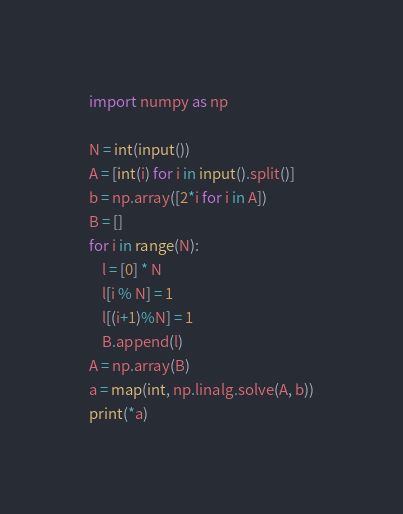<code> <loc_0><loc_0><loc_500><loc_500><_Python_>import numpy as np

N = int(input())
A = [int(i) for i in input().split()]
b = np.array([2*i for i in A])
B = []
for i in range(N):
    l = [0] * N
    l[i % N] = 1
    l[(i+1)%N] = 1
    B.append(l)
A = np.array(B)
a = map(int, np.linalg.solve(A, b))
print(*a)</code> 